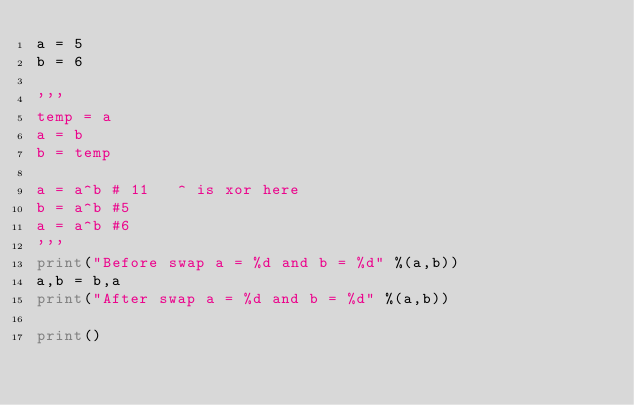<code> <loc_0><loc_0><loc_500><loc_500><_Python_>a = 5
b = 6

'''
temp = a
a = b
b = temp

a = a^b # 11   ^ is xor here
b = a^b #5
a = a^b #6
'''
print("Before swap a = %d and b = %d" %(a,b))
a,b = b,a
print("After swap a = %d and b = %d" %(a,b))

print()</code> 